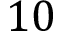<formula> <loc_0><loc_0><loc_500><loc_500>1 0</formula> 